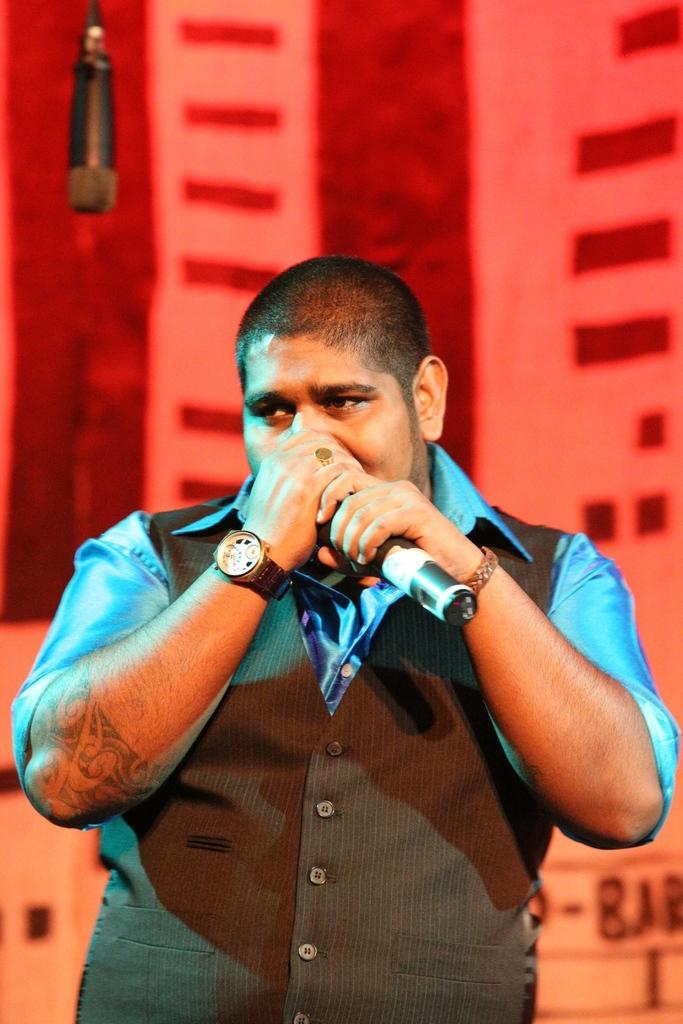How would you summarize this image in a sentence or two? In this image I see a man who is holding a mic near to his mouth. 